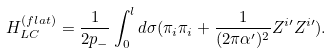<formula> <loc_0><loc_0><loc_500><loc_500>H _ { L C } ^ { ( f l a t ) } = \frac { 1 } { 2 p _ { - } } \int _ { 0 } ^ { l } d \sigma ( \pi _ { i } \pi _ { i } + \frac { 1 } { ( 2 \pi \alpha ^ { \prime } ) ^ { 2 } } Z ^ { i \prime } Z ^ { i \prime } ) .</formula> 